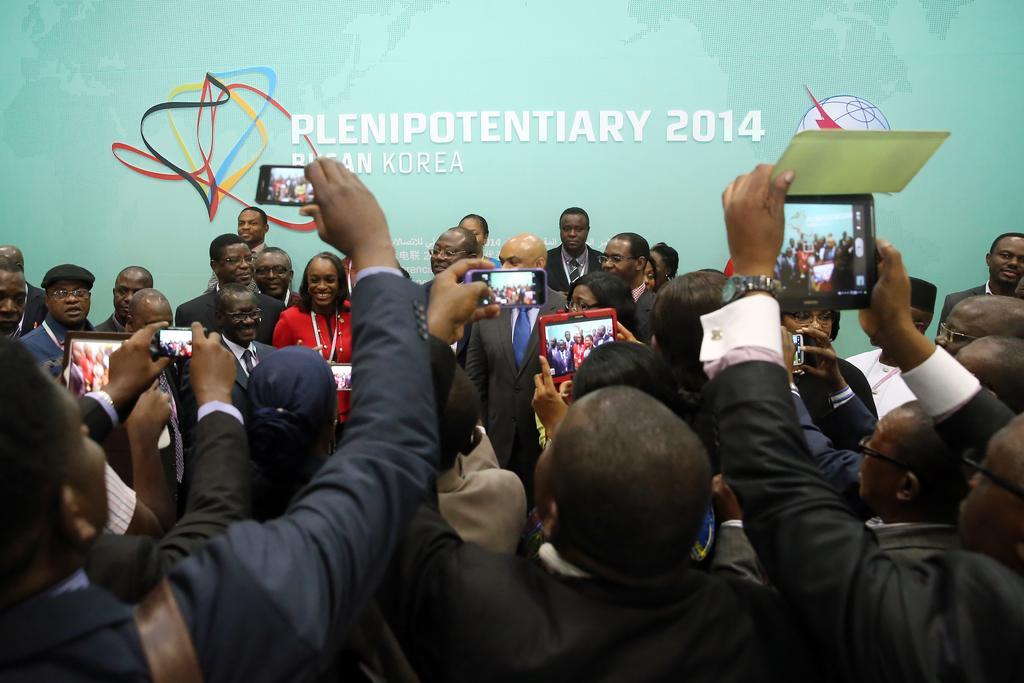Please provide a concise description of this image. In this picture we can observe some people standing and taking photographs and videos with their mobile phones and tablets. We can observe men and women in this picture. Some of them were smiling. In the background we can observe green color poster. 